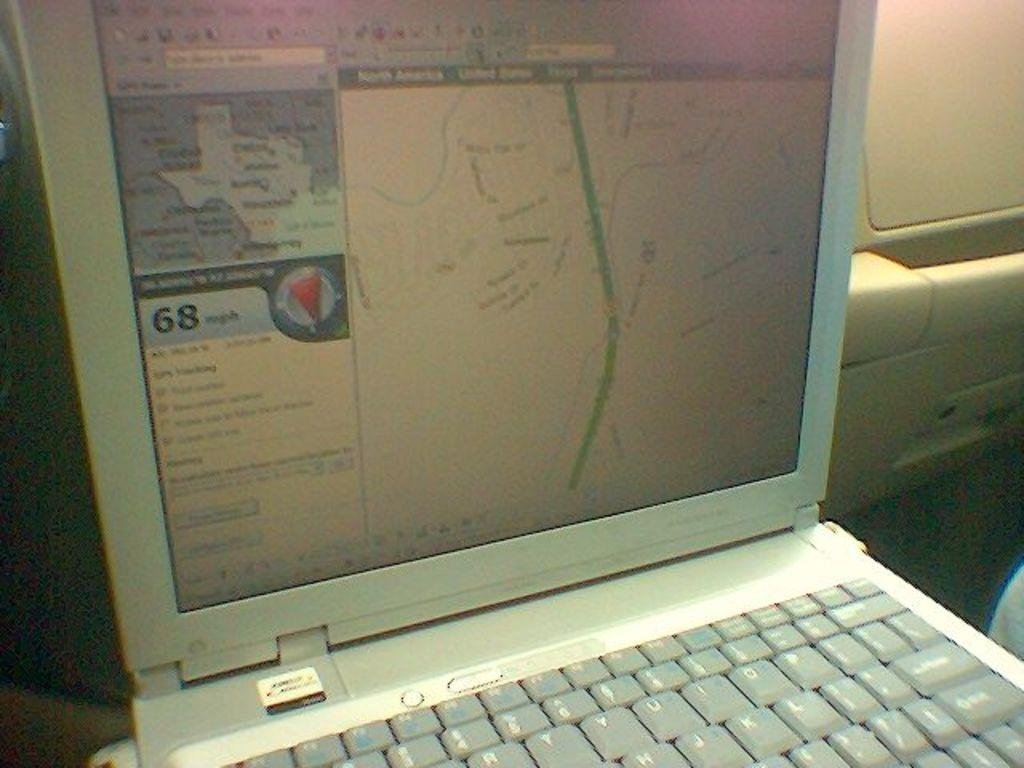<image>
Offer a succinct explanation of the picture presented. a computer laptop showing a vehicle moving at 68 mph on the screen 